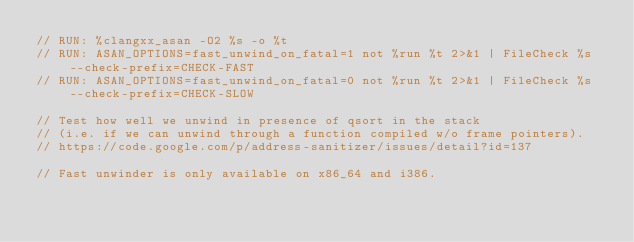Convert code to text. <code><loc_0><loc_0><loc_500><loc_500><_C++_>// RUN: %clangxx_asan -O2 %s -o %t
// RUN: ASAN_OPTIONS=fast_unwind_on_fatal=1 not %run %t 2>&1 | FileCheck %s --check-prefix=CHECK-FAST
// RUN: ASAN_OPTIONS=fast_unwind_on_fatal=0 not %run %t 2>&1 | FileCheck %s --check-prefix=CHECK-SLOW

// Test how well we unwind in presence of qsort in the stack
// (i.e. if we can unwind through a function compiled w/o frame pointers).
// https://code.google.com/p/address-sanitizer/issues/detail?id=137

// Fast unwinder is only available on x86_64 and i386.</code> 